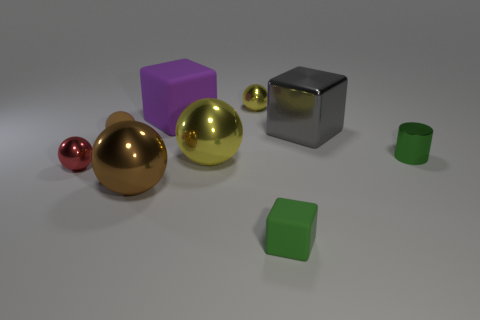Subtract all red spheres. How many spheres are left? 4 Subtract all purple balls. Subtract all cyan cylinders. How many balls are left? 5 Subtract all spheres. How many objects are left? 4 Subtract 0 yellow cubes. How many objects are left? 9 Subtract all green blocks. Subtract all yellow matte objects. How many objects are left? 8 Add 7 brown metallic things. How many brown metallic things are left? 8 Add 8 large blue cylinders. How many large blue cylinders exist? 8 